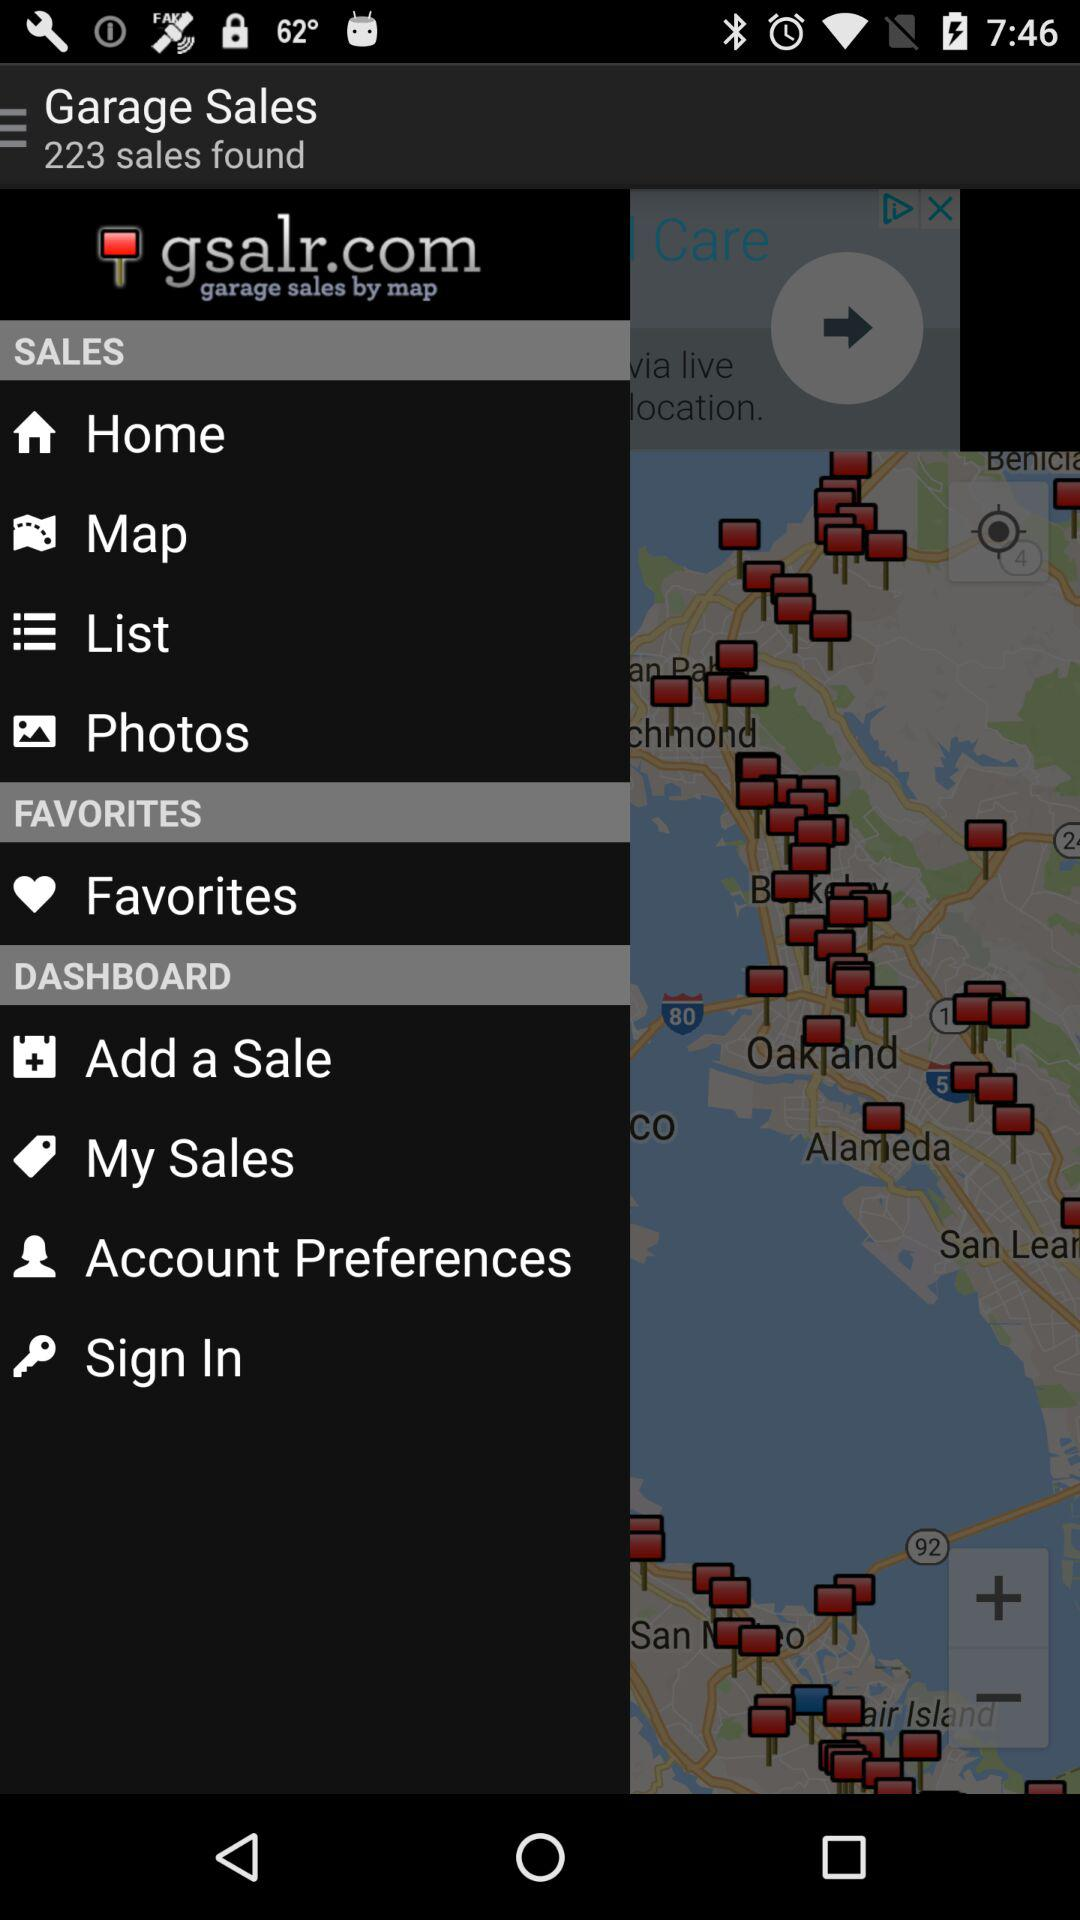What's the total number of sales found? The total number of sales found is 223. 